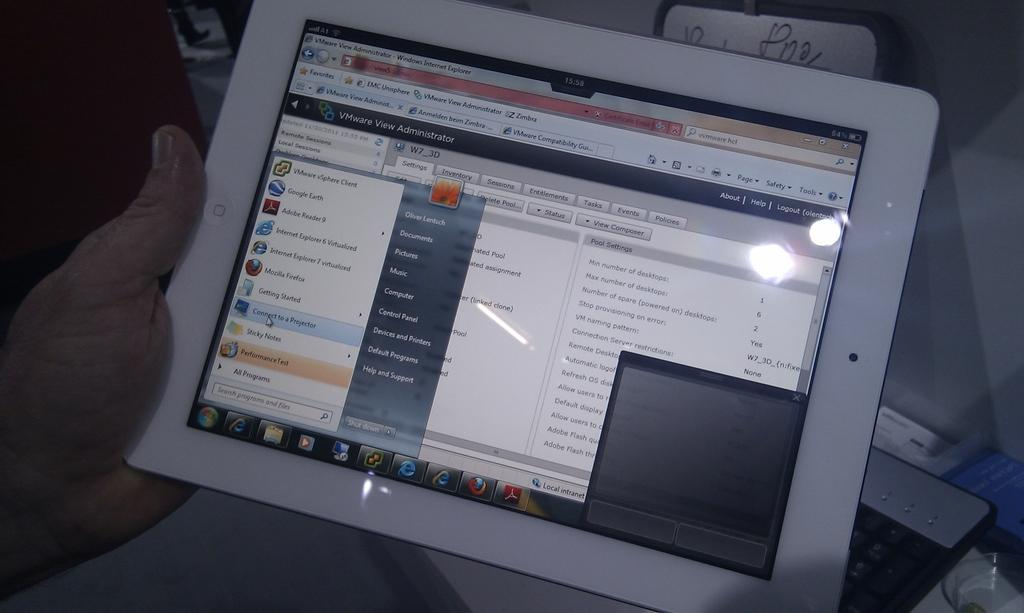What is the main subject of the image? The main subject of the image is a group of children playing in a playground. What types of playground equipment can be seen in the image? There is a slide, a swing, and a seesaw in the playground. How many girls are playing on the quarter in the image? There is no quarter present in the image, and no girls are playing on it. How many houses can be seen in the background of the image? There is no mention of houses in the image, so it cannot be determined how many are visible in the background. 